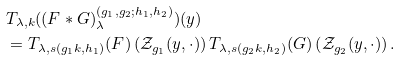<formula> <loc_0><loc_0><loc_500><loc_500>& T _ { \lambda , k } ( ( F * G ) _ { \lambda } ^ { ( g _ { 1 } , g _ { 2 } ; h _ { 1 } , h _ { 2 } ) } ) ( y ) \\ & = T _ { \lambda , s ( g _ { 1 } k , h _ { 1 } ) } ( F ) \left ( \mathcal { Z } _ { g _ { 1 } } ( y , \cdot ) \right ) T _ { \lambda , s ( g _ { 2 } k , h _ { 2 } ) } ( G ) \left ( \mathcal { Z } _ { g _ { 2 } } ( y , \cdot ) \right ) . \\</formula> 